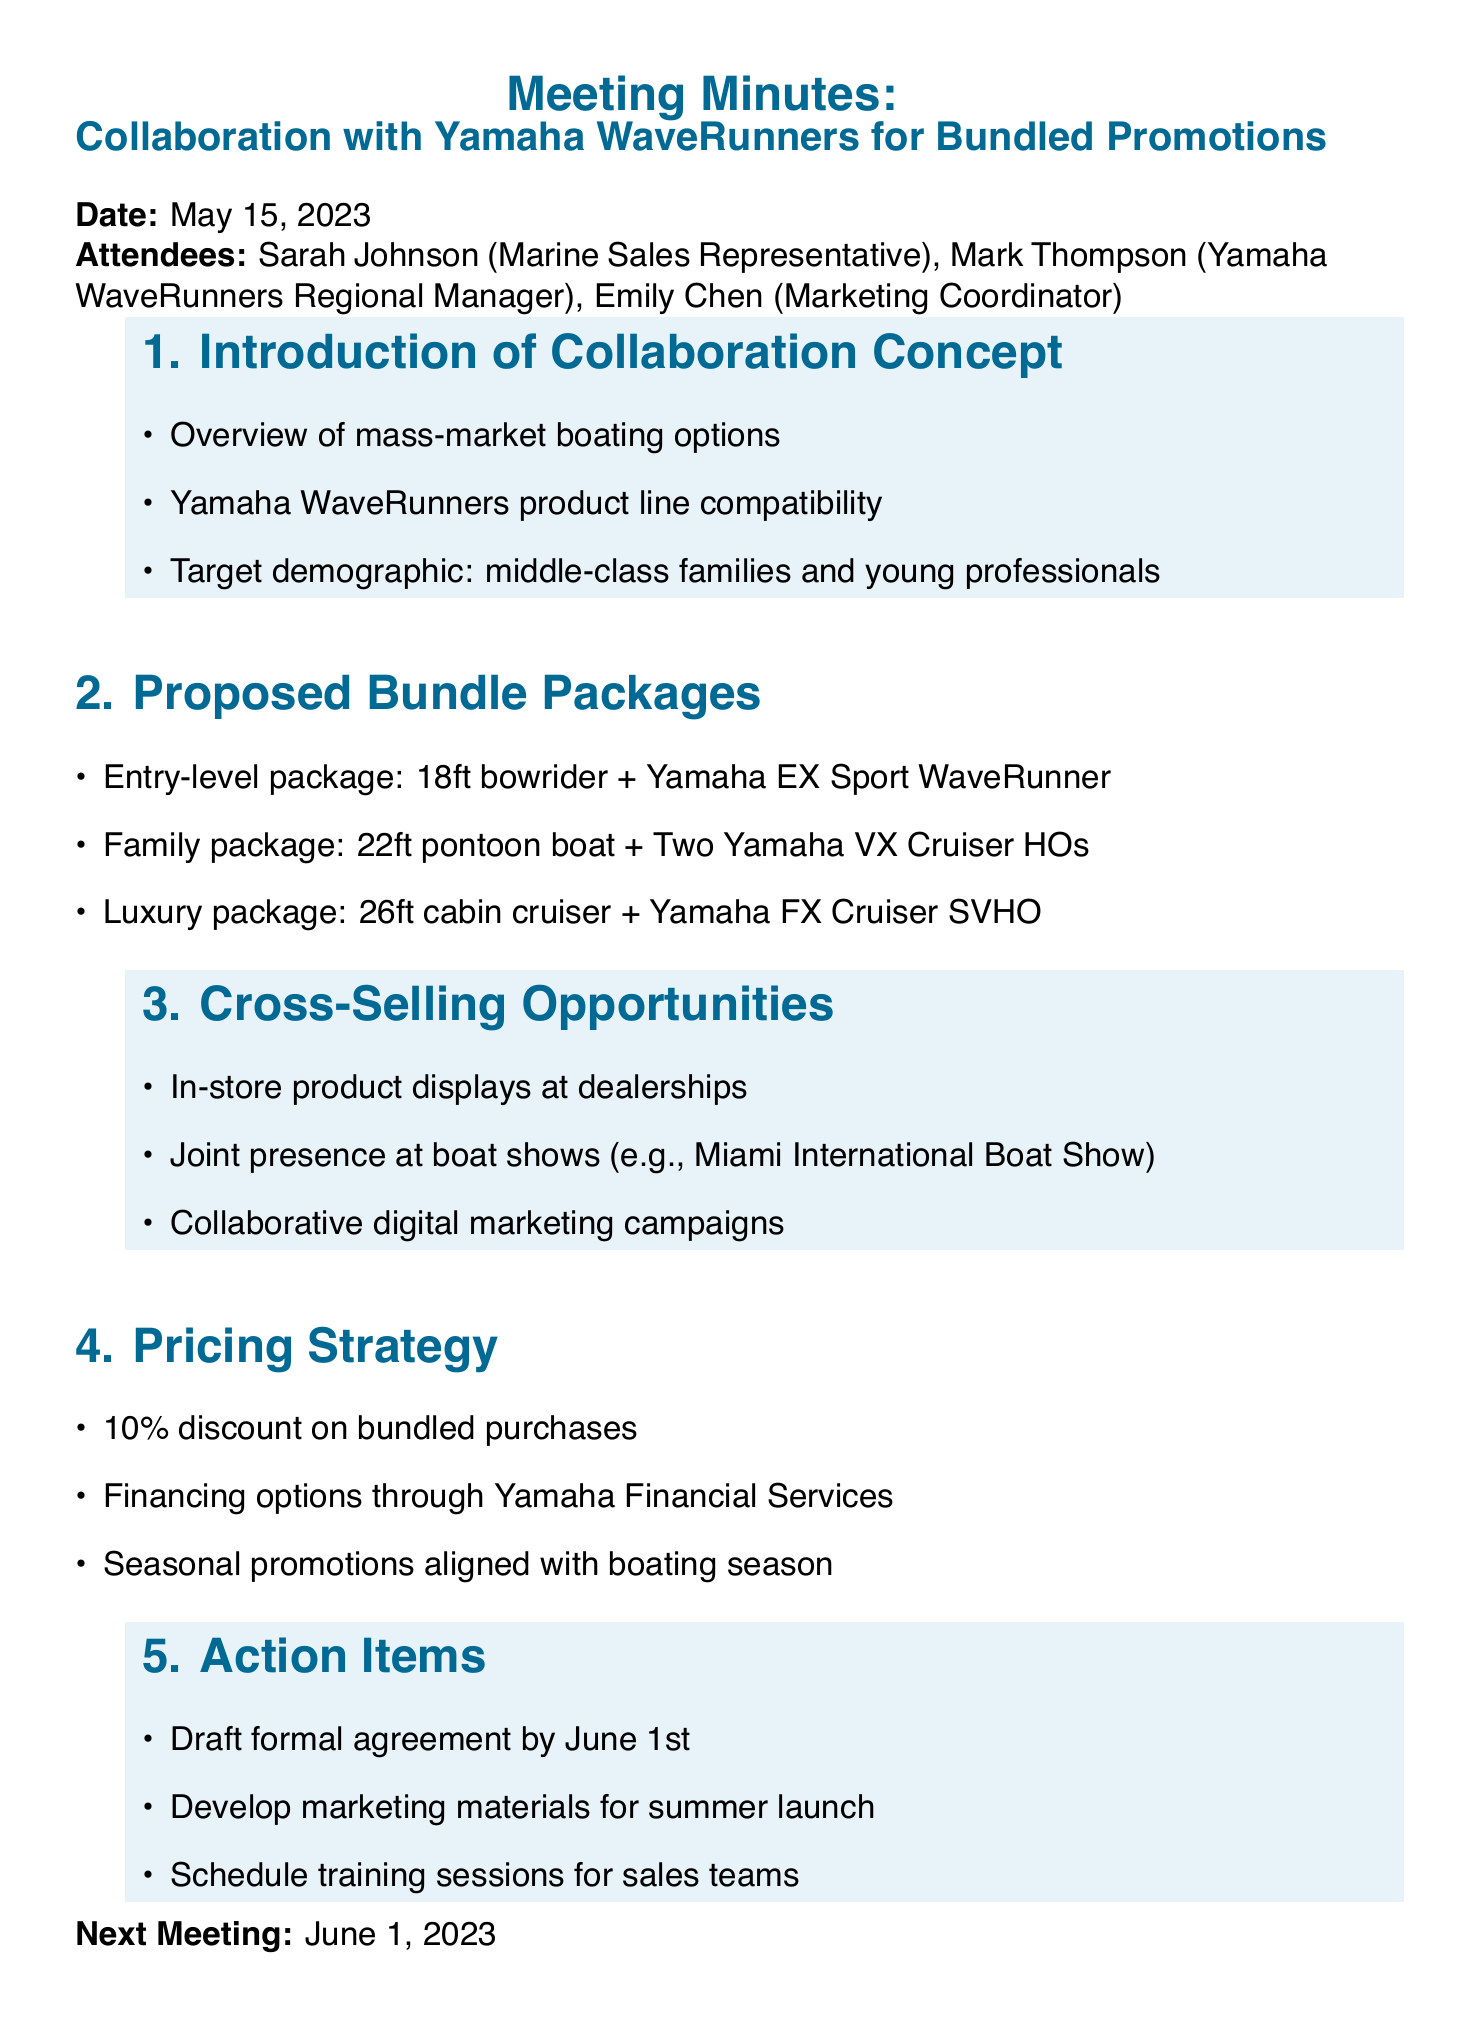What is the date of the meeting? The date of the meeting is stated in the document as May 15, 2023.
Answer: May 15, 2023 Who is the regional manager for Yamaha WaveRunners? The document lists Mark Thompson as the Yamaha WaveRunners Regional Manager.
Answer: Mark Thompson What is included in the family package? The family package consists of a 22ft pontoon boat and two Yamaha VX Cruiser HOs as outlined in the proposed bundle packages.
Answer: 22ft pontoon boat + Two Yamaha VX Cruiser HOs What discount is offered on bundled purchases? The document specifies a 10% discount on bundled purchases as part of the pricing strategy.
Answer: 10% What is the deadline for drafting the formal agreement? According to the action items section, the formal agreement should be drafted by June 1st.
Answer: June 1st What demographic is targeted for this collaboration? The document indicates that the target demographic includes middle-class families and young professionals.
Answer: Middle-class families and young professionals What are the cross-selling opportunities mentioned? The document lists in-store product displays at dealerships, joint presence at boat shows, and collaborative digital marketing campaigns as cross-selling opportunities.
Answer: In-store product displays, joint presence at boat shows, collaborative digital marketing campaigns What is the purpose of the next meeting? The next meeting is scheduled for June 1, 2023, to potentially discuss progress on the collaboration plans and action items.
Answer: June 1, 2023 